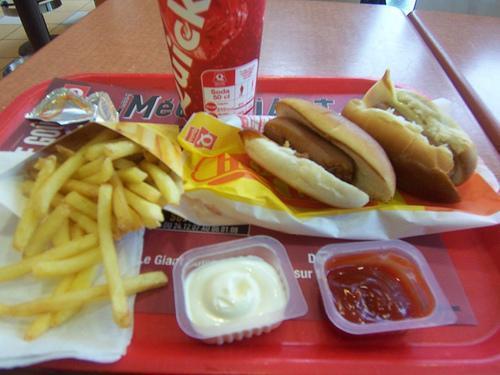What is being dipped in the red sauce?
From the following four choices, select the correct answer to address the question.
Options: Fries, hot dog, drink, bread. Fries. 